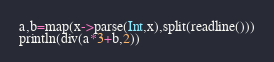Convert code to text. <code><loc_0><loc_0><loc_500><loc_500><_Julia_>a,b=map(x->parse(Int,x),split(readline()))
println(div(a*3+b,2))</code> 